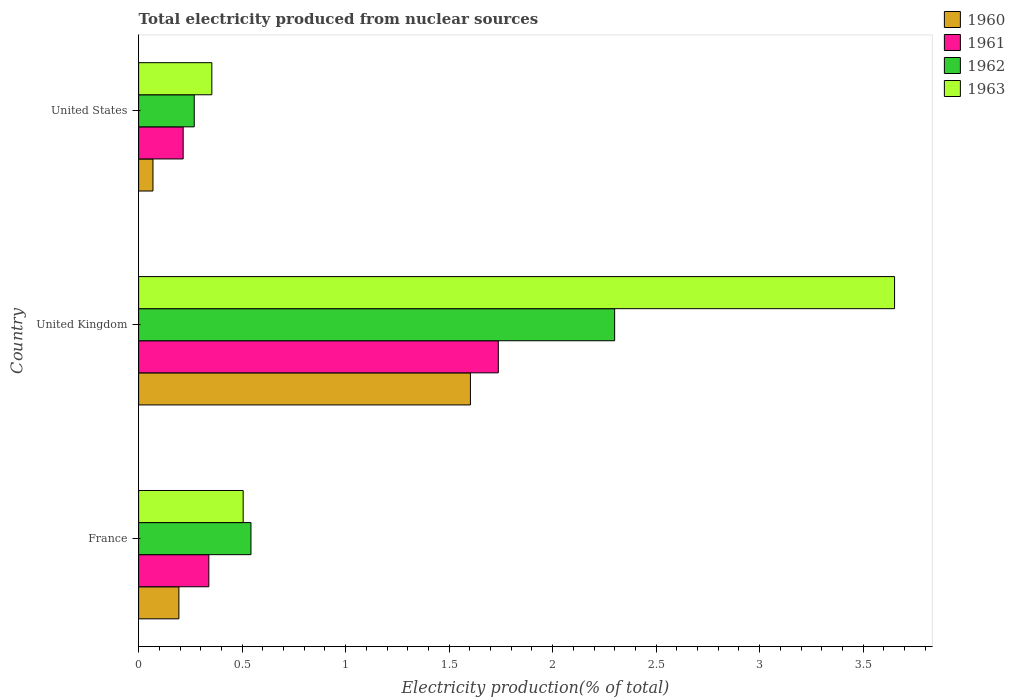How many bars are there on the 3rd tick from the top?
Offer a very short reply. 4. How many bars are there on the 1st tick from the bottom?
Offer a very short reply. 4. What is the label of the 2nd group of bars from the top?
Offer a terse response. United Kingdom. In how many cases, is the number of bars for a given country not equal to the number of legend labels?
Offer a very short reply. 0. What is the total electricity produced in 1960 in United Kingdom?
Offer a terse response. 1.6. Across all countries, what is the maximum total electricity produced in 1960?
Provide a succinct answer. 1.6. Across all countries, what is the minimum total electricity produced in 1962?
Offer a terse response. 0.27. In which country was the total electricity produced in 1960 minimum?
Your response must be concise. United States. What is the total total electricity produced in 1963 in the graph?
Give a very brief answer. 4.51. What is the difference between the total electricity produced in 1961 in France and that in United Kingdom?
Make the answer very short. -1.4. What is the difference between the total electricity produced in 1961 in France and the total electricity produced in 1962 in United Kingdom?
Provide a short and direct response. -1.96. What is the average total electricity produced in 1961 per country?
Provide a short and direct response. 0.76. What is the difference between the total electricity produced in 1961 and total electricity produced in 1963 in United Kingdom?
Your answer should be very brief. -1.91. In how many countries, is the total electricity produced in 1962 greater than 3.5 %?
Your answer should be very brief. 0. What is the ratio of the total electricity produced in 1962 in France to that in United Kingdom?
Provide a succinct answer. 0.24. Is the difference between the total electricity produced in 1961 in United Kingdom and United States greater than the difference between the total electricity produced in 1963 in United Kingdom and United States?
Provide a short and direct response. No. What is the difference between the highest and the second highest total electricity produced in 1960?
Provide a short and direct response. 1.41. What is the difference between the highest and the lowest total electricity produced in 1962?
Keep it short and to the point. 2.03. In how many countries, is the total electricity produced in 1961 greater than the average total electricity produced in 1961 taken over all countries?
Offer a very short reply. 1. Is the sum of the total electricity produced in 1961 in United Kingdom and United States greater than the maximum total electricity produced in 1962 across all countries?
Keep it short and to the point. No. Is it the case that in every country, the sum of the total electricity produced in 1962 and total electricity produced in 1963 is greater than the sum of total electricity produced in 1960 and total electricity produced in 1961?
Provide a succinct answer. No. What does the 1st bar from the bottom in United States represents?
Offer a terse response. 1960. How many bars are there?
Make the answer very short. 12. Are all the bars in the graph horizontal?
Keep it short and to the point. Yes. How many countries are there in the graph?
Your answer should be very brief. 3. What is the difference between two consecutive major ticks on the X-axis?
Your answer should be compact. 0.5. Are the values on the major ticks of X-axis written in scientific E-notation?
Give a very brief answer. No. How many legend labels are there?
Provide a succinct answer. 4. What is the title of the graph?
Offer a very short reply. Total electricity produced from nuclear sources. Does "1973" appear as one of the legend labels in the graph?
Keep it short and to the point. No. What is the Electricity production(% of total) in 1960 in France?
Your response must be concise. 0.19. What is the Electricity production(% of total) of 1961 in France?
Make the answer very short. 0.34. What is the Electricity production(% of total) of 1962 in France?
Offer a terse response. 0.54. What is the Electricity production(% of total) in 1963 in France?
Keep it short and to the point. 0.51. What is the Electricity production(% of total) of 1960 in United Kingdom?
Keep it short and to the point. 1.6. What is the Electricity production(% of total) of 1961 in United Kingdom?
Offer a terse response. 1.74. What is the Electricity production(% of total) in 1962 in United Kingdom?
Provide a short and direct response. 2.3. What is the Electricity production(% of total) in 1963 in United Kingdom?
Make the answer very short. 3.65. What is the Electricity production(% of total) in 1960 in United States?
Give a very brief answer. 0.07. What is the Electricity production(% of total) in 1961 in United States?
Ensure brevity in your answer.  0.22. What is the Electricity production(% of total) of 1962 in United States?
Make the answer very short. 0.27. What is the Electricity production(% of total) in 1963 in United States?
Make the answer very short. 0.35. Across all countries, what is the maximum Electricity production(% of total) in 1960?
Offer a terse response. 1.6. Across all countries, what is the maximum Electricity production(% of total) in 1961?
Provide a short and direct response. 1.74. Across all countries, what is the maximum Electricity production(% of total) of 1962?
Provide a succinct answer. 2.3. Across all countries, what is the maximum Electricity production(% of total) in 1963?
Offer a terse response. 3.65. Across all countries, what is the minimum Electricity production(% of total) in 1960?
Make the answer very short. 0.07. Across all countries, what is the minimum Electricity production(% of total) of 1961?
Offer a very short reply. 0.22. Across all countries, what is the minimum Electricity production(% of total) of 1962?
Your response must be concise. 0.27. Across all countries, what is the minimum Electricity production(% of total) in 1963?
Keep it short and to the point. 0.35. What is the total Electricity production(% of total) in 1960 in the graph?
Your answer should be compact. 1.87. What is the total Electricity production(% of total) in 1961 in the graph?
Your answer should be compact. 2.29. What is the total Electricity production(% of total) of 1962 in the graph?
Keep it short and to the point. 3.11. What is the total Electricity production(% of total) in 1963 in the graph?
Provide a succinct answer. 4.51. What is the difference between the Electricity production(% of total) of 1960 in France and that in United Kingdom?
Offer a terse response. -1.41. What is the difference between the Electricity production(% of total) of 1961 in France and that in United Kingdom?
Your answer should be compact. -1.4. What is the difference between the Electricity production(% of total) in 1962 in France and that in United Kingdom?
Offer a very short reply. -1.76. What is the difference between the Electricity production(% of total) in 1963 in France and that in United Kingdom?
Your answer should be very brief. -3.15. What is the difference between the Electricity production(% of total) in 1960 in France and that in United States?
Give a very brief answer. 0.13. What is the difference between the Electricity production(% of total) of 1961 in France and that in United States?
Ensure brevity in your answer.  0.12. What is the difference between the Electricity production(% of total) of 1962 in France and that in United States?
Give a very brief answer. 0.27. What is the difference between the Electricity production(% of total) of 1963 in France and that in United States?
Ensure brevity in your answer.  0.15. What is the difference between the Electricity production(% of total) of 1960 in United Kingdom and that in United States?
Your answer should be very brief. 1.53. What is the difference between the Electricity production(% of total) in 1961 in United Kingdom and that in United States?
Keep it short and to the point. 1.52. What is the difference between the Electricity production(% of total) in 1962 in United Kingdom and that in United States?
Give a very brief answer. 2.03. What is the difference between the Electricity production(% of total) in 1963 in United Kingdom and that in United States?
Ensure brevity in your answer.  3.3. What is the difference between the Electricity production(% of total) in 1960 in France and the Electricity production(% of total) in 1961 in United Kingdom?
Provide a short and direct response. -1.54. What is the difference between the Electricity production(% of total) of 1960 in France and the Electricity production(% of total) of 1962 in United Kingdom?
Your answer should be compact. -2.11. What is the difference between the Electricity production(% of total) in 1960 in France and the Electricity production(% of total) in 1963 in United Kingdom?
Provide a succinct answer. -3.46. What is the difference between the Electricity production(% of total) of 1961 in France and the Electricity production(% of total) of 1962 in United Kingdom?
Offer a terse response. -1.96. What is the difference between the Electricity production(% of total) of 1961 in France and the Electricity production(% of total) of 1963 in United Kingdom?
Your answer should be compact. -3.31. What is the difference between the Electricity production(% of total) in 1962 in France and the Electricity production(% of total) in 1963 in United Kingdom?
Provide a succinct answer. -3.11. What is the difference between the Electricity production(% of total) in 1960 in France and the Electricity production(% of total) in 1961 in United States?
Provide a succinct answer. -0.02. What is the difference between the Electricity production(% of total) in 1960 in France and the Electricity production(% of total) in 1962 in United States?
Your answer should be compact. -0.07. What is the difference between the Electricity production(% of total) of 1960 in France and the Electricity production(% of total) of 1963 in United States?
Your response must be concise. -0.16. What is the difference between the Electricity production(% of total) in 1961 in France and the Electricity production(% of total) in 1962 in United States?
Provide a short and direct response. 0.07. What is the difference between the Electricity production(% of total) in 1961 in France and the Electricity production(% of total) in 1963 in United States?
Offer a terse response. -0.01. What is the difference between the Electricity production(% of total) of 1962 in France and the Electricity production(% of total) of 1963 in United States?
Your answer should be very brief. 0.19. What is the difference between the Electricity production(% of total) of 1960 in United Kingdom and the Electricity production(% of total) of 1961 in United States?
Your response must be concise. 1.39. What is the difference between the Electricity production(% of total) in 1960 in United Kingdom and the Electricity production(% of total) in 1962 in United States?
Your answer should be very brief. 1.33. What is the difference between the Electricity production(% of total) in 1960 in United Kingdom and the Electricity production(% of total) in 1963 in United States?
Provide a succinct answer. 1.25. What is the difference between the Electricity production(% of total) of 1961 in United Kingdom and the Electricity production(% of total) of 1962 in United States?
Offer a very short reply. 1.47. What is the difference between the Electricity production(% of total) of 1961 in United Kingdom and the Electricity production(% of total) of 1963 in United States?
Make the answer very short. 1.38. What is the difference between the Electricity production(% of total) of 1962 in United Kingdom and the Electricity production(% of total) of 1963 in United States?
Your response must be concise. 1.95. What is the average Electricity production(% of total) in 1960 per country?
Give a very brief answer. 0.62. What is the average Electricity production(% of total) in 1961 per country?
Make the answer very short. 0.76. What is the average Electricity production(% of total) in 1962 per country?
Offer a terse response. 1.04. What is the average Electricity production(% of total) of 1963 per country?
Your answer should be very brief. 1.5. What is the difference between the Electricity production(% of total) of 1960 and Electricity production(% of total) of 1961 in France?
Give a very brief answer. -0.14. What is the difference between the Electricity production(% of total) of 1960 and Electricity production(% of total) of 1962 in France?
Your response must be concise. -0.35. What is the difference between the Electricity production(% of total) in 1960 and Electricity production(% of total) in 1963 in France?
Give a very brief answer. -0.31. What is the difference between the Electricity production(% of total) of 1961 and Electricity production(% of total) of 1962 in France?
Provide a succinct answer. -0.2. What is the difference between the Electricity production(% of total) in 1961 and Electricity production(% of total) in 1963 in France?
Your response must be concise. -0.17. What is the difference between the Electricity production(% of total) in 1962 and Electricity production(% of total) in 1963 in France?
Your answer should be compact. 0.04. What is the difference between the Electricity production(% of total) of 1960 and Electricity production(% of total) of 1961 in United Kingdom?
Your answer should be very brief. -0.13. What is the difference between the Electricity production(% of total) in 1960 and Electricity production(% of total) in 1962 in United Kingdom?
Keep it short and to the point. -0.7. What is the difference between the Electricity production(% of total) of 1960 and Electricity production(% of total) of 1963 in United Kingdom?
Provide a succinct answer. -2.05. What is the difference between the Electricity production(% of total) in 1961 and Electricity production(% of total) in 1962 in United Kingdom?
Make the answer very short. -0.56. What is the difference between the Electricity production(% of total) in 1961 and Electricity production(% of total) in 1963 in United Kingdom?
Offer a very short reply. -1.91. What is the difference between the Electricity production(% of total) in 1962 and Electricity production(% of total) in 1963 in United Kingdom?
Ensure brevity in your answer.  -1.35. What is the difference between the Electricity production(% of total) in 1960 and Electricity production(% of total) in 1961 in United States?
Give a very brief answer. -0.15. What is the difference between the Electricity production(% of total) in 1960 and Electricity production(% of total) in 1962 in United States?
Ensure brevity in your answer.  -0.2. What is the difference between the Electricity production(% of total) in 1960 and Electricity production(% of total) in 1963 in United States?
Offer a very short reply. -0.28. What is the difference between the Electricity production(% of total) in 1961 and Electricity production(% of total) in 1962 in United States?
Give a very brief answer. -0.05. What is the difference between the Electricity production(% of total) in 1961 and Electricity production(% of total) in 1963 in United States?
Your answer should be very brief. -0.14. What is the difference between the Electricity production(% of total) of 1962 and Electricity production(% of total) of 1963 in United States?
Your response must be concise. -0.09. What is the ratio of the Electricity production(% of total) in 1960 in France to that in United Kingdom?
Keep it short and to the point. 0.12. What is the ratio of the Electricity production(% of total) in 1961 in France to that in United Kingdom?
Provide a short and direct response. 0.2. What is the ratio of the Electricity production(% of total) of 1962 in France to that in United Kingdom?
Provide a succinct answer. 0.24. What is the ratio of the Electricity production(% of total) of 1963 in France to that in United Kingdom?
Offer a very short reply. 0.14. What is the ratio of the Electricity production(% of total) in 1960 in France to that in United States?
Ensure brevity in your answer.  2.81. What is the ratio of the Electricity production(% of total) of 1961 in France to that in United States?
Make the answer very short. 1.58. What is the ratio of the Electricity production(% of total) of 1962 in France to that in United States?
Your response must be concise. 2.02. What is the ratio of the Electricity production(% of total) of 1963 in France to that in United States?
Provide a short and direct response. 1.43. What is the ratio of the Electricity production(% of total) of 1960 in United Kingdom to that in United States?
Provide a short and direct response. 23.14. What is the ratio of the Electricity production(% of total) in 1961 in United Kingdom to that in United States?
Give a very brief answer. 8.08. What is the ratio of the Electricity production(% of total) in 1962 in United Kingdom to that in United States?
Make the answer very short. 8.56. What is the ratio of the Electricity production(% of total) in 1963 in United Kingdom to that in United States?
Offer a terse response. 10.32. What is the difference between the highest and the second highest Electricity production(% of total) of 1960?
Your answer should be compact. 1.41. What is the difference between the highest and the second highest Electricity production(% of total) in 1961?
Provide a succinct answer. 1.4. What is the difference between the highest and the second highest Electricity production(% of total) of 1962?
Offer a very short reply. 1.76. What is the difference between the highest and the second highest Electricity production(% of total) of 1963?
Provide a succinct answer. 3.15. What is the difference between the highest and the lowest Electricity production(% of total) of 1960?
Your answer should be compact. 1.53. What is the difference between the highest and the lowest Electricity production(% of total) of 1961?
Your answer should be compact. 1.52. What is the difference between the highest and the lowest Electricity production(% of total) of 1962?
Give a very brief answer. 2.03. What is the difference between the highest and the lowest Electricity production(% of total) of 1963?
Make the answer very short. 3.3. 